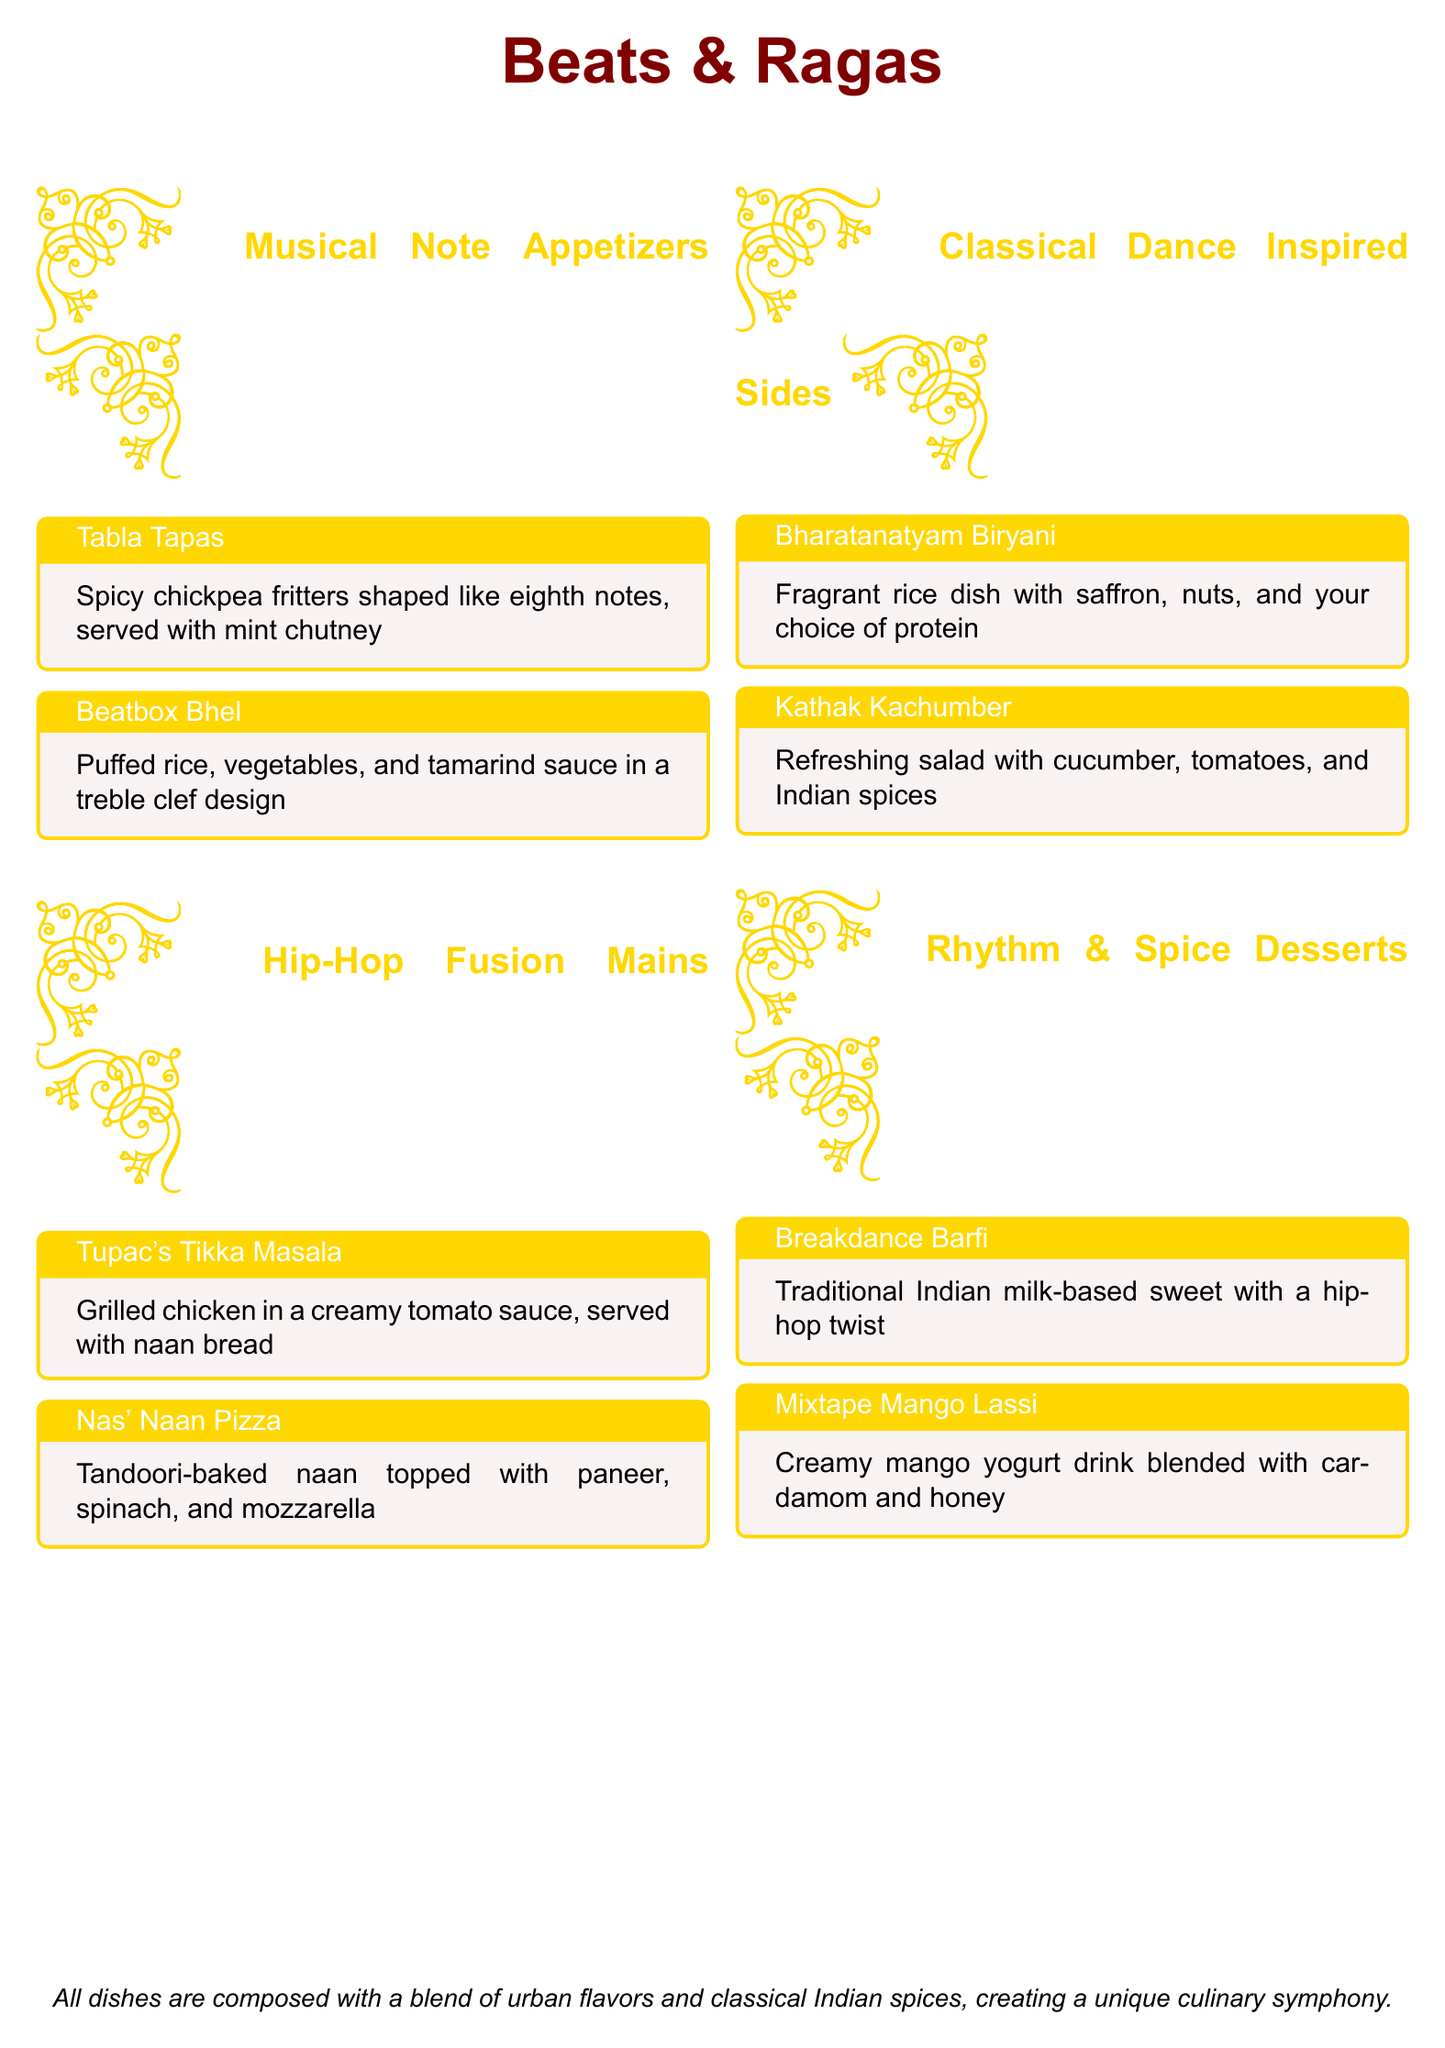What is the name of the appetizer shaped like eighth notes? The appetizer shaped like eighth notes is called "Tabla Tapas."
Answer: Tabla Tapas What dish is inspired by Tupac? The dish inspired by Tupac is "Tupac's Tikka Masala."
Answer: Tupac's Tikka Masala What is the main ingredient in the Beatbox Bhel? The main ingredient in the Beatbox Bhel is puffed rice.
Answer: Puffed rice Which dessert is a traditional Indian sweet with a hip-hop twist? The dessert that is a traditional Indian sweet with a hip-hop twist is "Breakdance Barfi."
Answer: Breakdance Barfi What kind of salad is served as a side dish? The side dish served is a refreshing salad called "Kathak Kachumber."
Answer: Kathak Kachumber How many musical note-shaped appetizers are listed? There are two musical note-shaped appetizers listed in the document.
Answer: Two What is the unique aspect of the dished presented in this menu? The unique aspect of the dishes presented is the blend of urban flavors and classical Indian spices.
Answer: Blend of urban flavors and classical Indian spices What drink is made creamy with mango and flavored with cardamom? The drink made creamy with mango and flavored with cardamom is "Mixtape Mango Lassi."
Answer: Mixtape Mango Lassi 